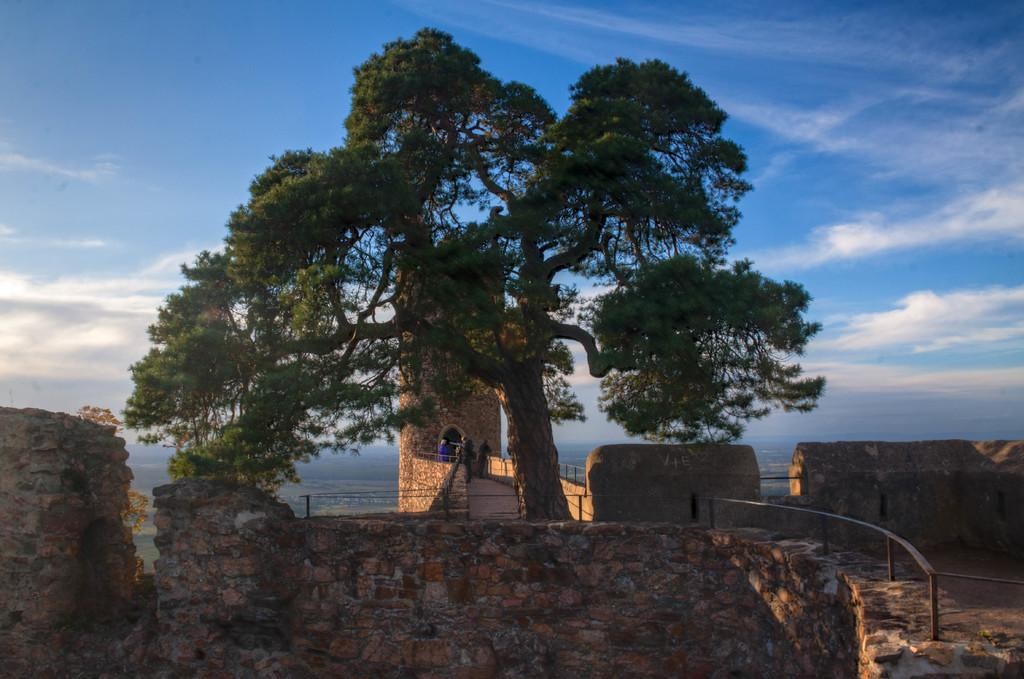What is the main subject of the image? The main subject of the image is a fort. Are there any people inside the fort? Yes, there are people in the fort. What can be seen on the right side of the image? There is a fence on the right side of the image. What type of vegetation is visible in the image? There is a tree visible in the image. How would you describe the sky in the image? The sky is blue and cloudy. What type of tramp is performing in the fort? There is no tramp performing in the image; it features a fort with people inside. Is there a birthday celebration happening in the fort? There is no indication of a birthday celebration in the image. 